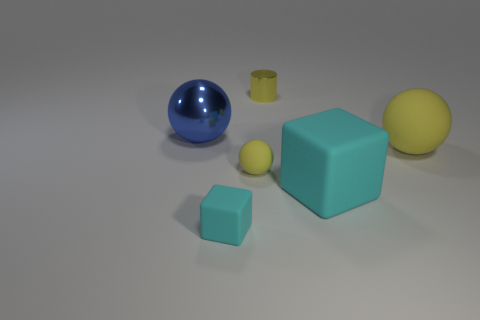What number of things are gray rubber objects or yellow metal things?
Keep it short and to the point. 1. How many other things are the same shape as the large yellow matte thing?
Offer a terse response. 2. Is the large sphere that is to the right of the tiny cyan block made of the same material as the tiny yellow object in front of the big rubber ball?
Make the answer very short. Yes. What is the shape of the object that is both to the left of the yellow metal object and behind the big yellow ball?
Make the answer very short. Sphere. There is a large thing that is behind the big cyan matte block and left of the large yellow sphere; what is it made of?
Make the answer very short. Metal. What shape is the small cyan thing that is the same material as the small ball?
Your response must be concise. Cube. Are there any other things that are the same color as the shiny ball?
Offer a terse response. No. Is the number of yellow metallic objects that are right of the blue metallic object greater than the number of tiny blue rubber cylinders?
Provide a short and direct response. Yes. What is the blue sphere made of?
Your response must be concise. Metal. What number of yellow balls have the same size as the cylinder?
Give a very brief answer. 1. 